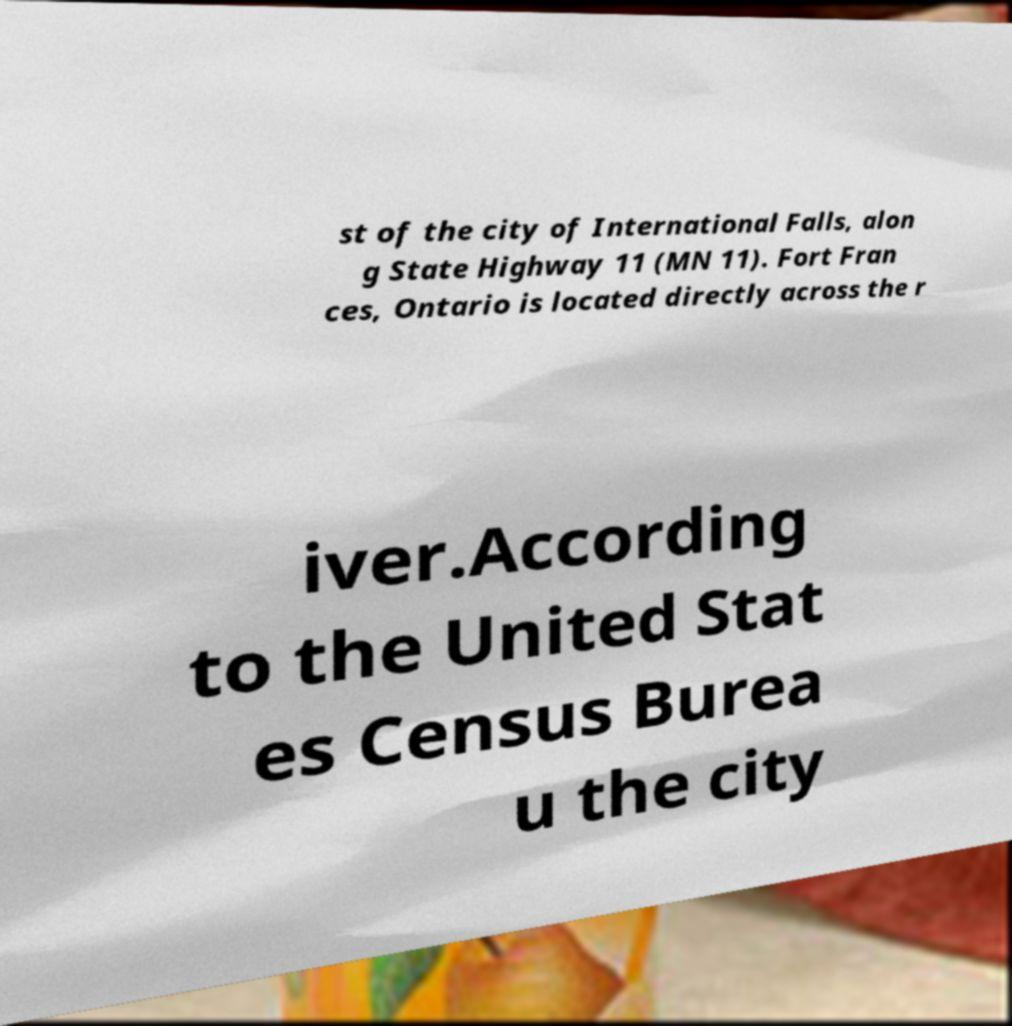Please identify and transcribe the text found in this image. st of the city of International Falls, alon g State Highway 11 (MN 11). Fort Fran ces, Ontario is located directly across the r iver.According to the United Stat es Census Burea u the city 